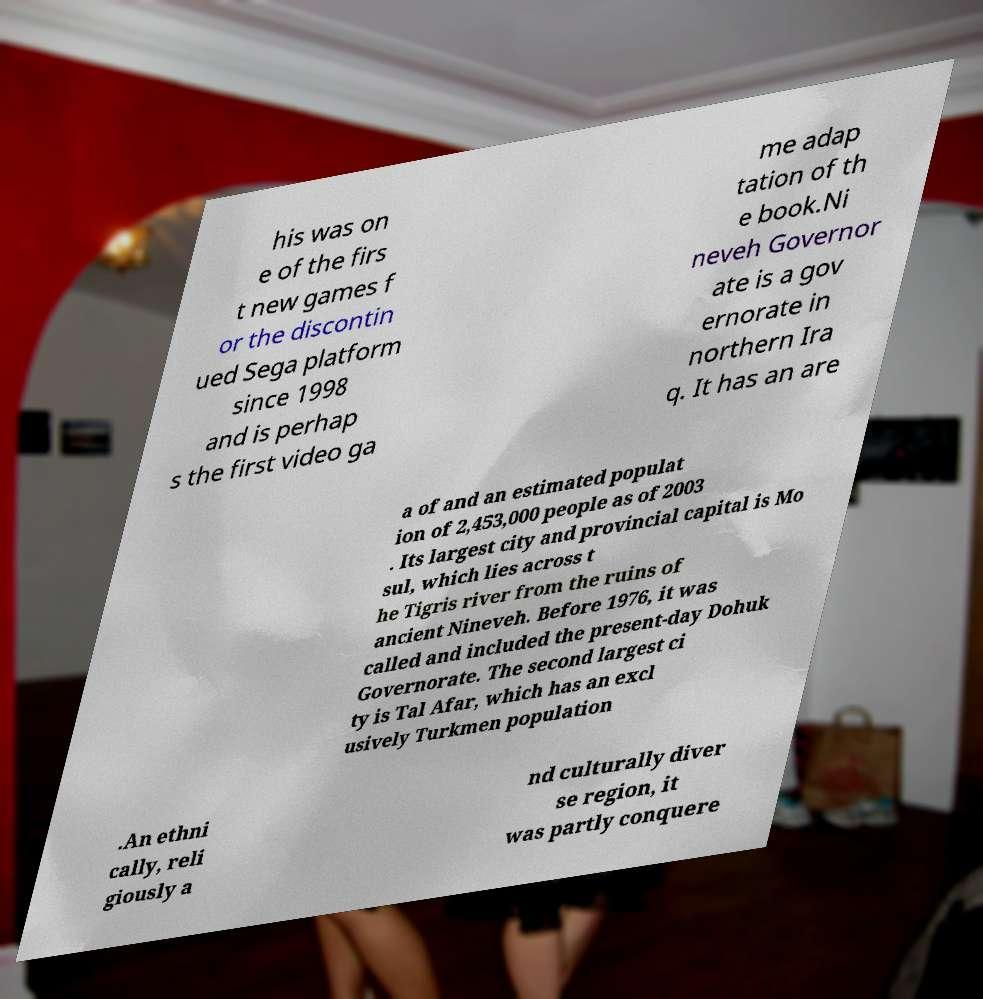I need the written content from this picture converted into text. Can you do that? his was on e of the firs t new games f or the discontin ued Sega platform since 1998 and is perhap s the first video ga me adap tation of th e book.Ni neveh Governor ate is a gov ernorate in northern Ira q. It has an are a of and an estimated populat ion of 2,453,000 people as of 2003 . Its largest city and provincial capital is Mo sul, which lies across t he Tigris river from the ruins of ancient Nineveh. Before 1976, it was called and included the present-day Dohuk Governorate. The second largest ci ty is Tal Afar, which has an excl usively Turkmen population .An ethni cally, reli giously a nd culturally diver se region, it was partly conquere 